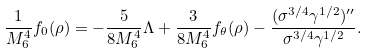Convert formula to latex. <formula><loc_0><loc_0><loc_500><loc_500>\frac { 1 } { M _ { 6 } ^ { 4 } } f _ { 0 } ( \rho ) = - \frac { 5 } { 8 M _ { 6 } ^ { 4 } } \Lambda + \frac { 3 } { 8 M _ { 6 } ^ { 4 } } f _ { \theta } ( \rho ) - \frac { ( \sigma ^ { 3 / 4 } \gamma ^ { 1 / 2 } ) ^ { \prime \prime } } { \sigma ^ { 3 / 4 } \gamma ^ { 1 / 2 } } .</formula> 